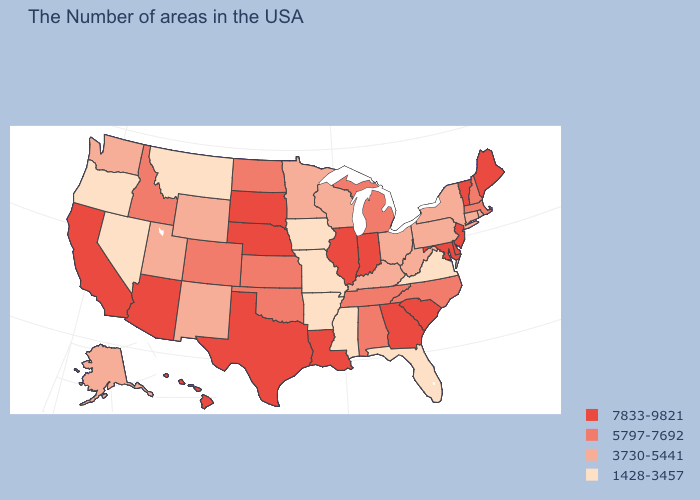Name the states that have a value in the range 7833-9821?
Write a very short answer. Maine, Vermont, New Jersey, Delaware, Maryland, South Carolina, Georgia, Indiana, Illinois, Louisiana, Nebraska, Texas, South Dakota, Arizona, California, Hawaii. What is the value of Arizona?
Give a very brief answer. 7833-9821. What is the value of North Carolina?
Short answer required. 5797-7692. Among the states that border Washington , does Idaho have the lowest value?
Short answer required. No. Among the states that border Kentucky , which have the highest value?
Quick response, please. Indiana, Illinois. Does the map have missing data?
Write a very short answer. No. Does Nevada have the lowest value in the USA?
Write a very short answer. Yes. Name the states that have a value in the range 7833-9821?
Short answer required. Maine, Vermont, New Jersey, Delaware, Maryland, South Carolina, Georgia, Indiana, Illinois, Louisiana, Nebraska, Texas, South Dakota, Arizona, California, Hawaii. Which states have the lowest value in the USA?
Write a very short answer. Virginia, Florida, Mississippi, Missouri, Arkansas, Iowa, Montana, Nevada, Oregon. Does Oklahoma have the same value as Hawaii?
Give a very brief answer. No. Name the states that have a value in the range 7833-9821?
Write a very short answer. Maine, Vermont, New Jersey, Delaware, Maryland, South Carolina, Georgia, Indiana, Illinois, Louisiana, Nebraska, Texas, South Dakota, Arizona, California, Hawaii. What is the value of New York?
Give a very brief answer. 3730-5441. Does North Carolina have the lowest value in the South?
Give a very brief answer. No. What is the lowest value in the MidWest?
Quick response, please. 1428-3457. Name the states that have a value in the range 7833-9821?
Be succinct. Maine, Vermont, New Jersey, Delaware, Maryland, South Carolina, Georgia, Indiana, Illinois, Louisiana, Nebraska, Texas, South Dakota, Arizona, California, Hawaii. 